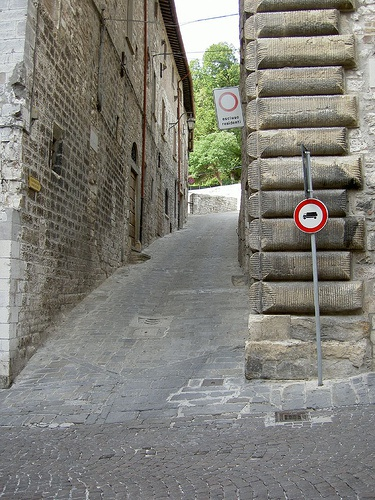Describe the objects in this image and their specific colors. I can see various objects in this image with different colors. 